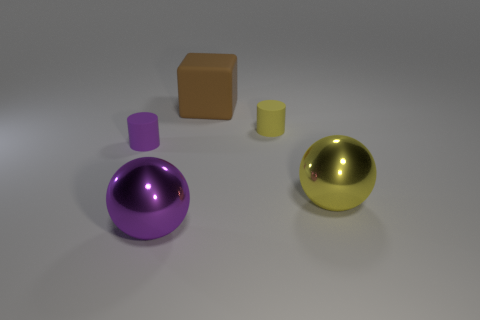What are the other objects in the image made of? In addition to the metal-like purple sphere, there is a brown block that resembles a matte, wooden cube and a smaller, shiny gold sphere similar in material appearance to the purple one, which implies it could also be metal. Finally, there's a small cylinder that has a less reflective, more muted surface, which could possibly be plastic or ceramic. 